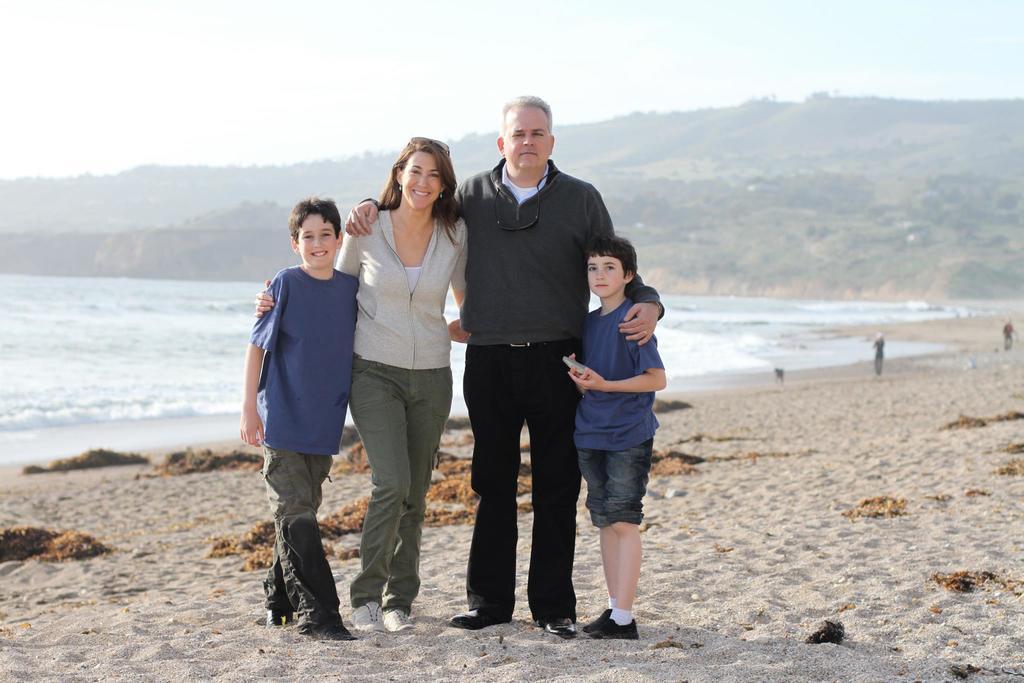How would you summarize this image in a sentence or two? This is the picture of a guy, lady and two kids who are standing in the beach. 